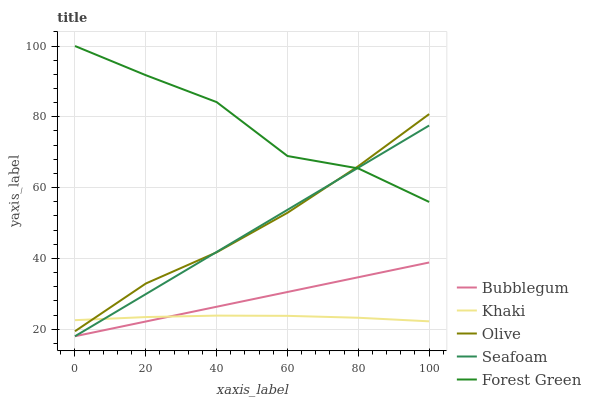Does Khaki have the minimum area under the curve?
Answer yes or no. Yes. Does Forest Green have the maximum area under the curve?
Answer yes or no. Yes. Does Forest Green have the minimum area under the curve?
Answer yes or no. No. Does Khaki have the maximum area under the curve?
Answer yes or no. No. Is Bubblegum the smoothest?
Answer yes or no. Yes. Is Forest Green the roughest?
Answer yes or no. Yes. Is Khaki the smoothest?
Answer yes or no. No. Is Khaki the roughest?
Answer yes or no. No. Does Seafoam have the lowest value?
Answer yes or no. Yes. Does Khaki have the lowest value?
Answer yes or no. No. Does Forest Green have the highest value?
Answer yes or no. Yes. Does Khaki have the highest value?
Answer yes or no. No. Is Khaki less than Forest Green?
Answer yes or no. Yes. Is Forest Green greater than Khaki?
Answer yes or no. Yes. Does Bubblegum intersect Seafoam?
Answer yes or no. Yes. Is Bubblegum less than Seafoam?
Answer yes or no. No. Is Bubblegum greater than Seafoam?
Answer yes or no. No. Does Khaki intersect Forest Green?
Answer yes or no. No. 